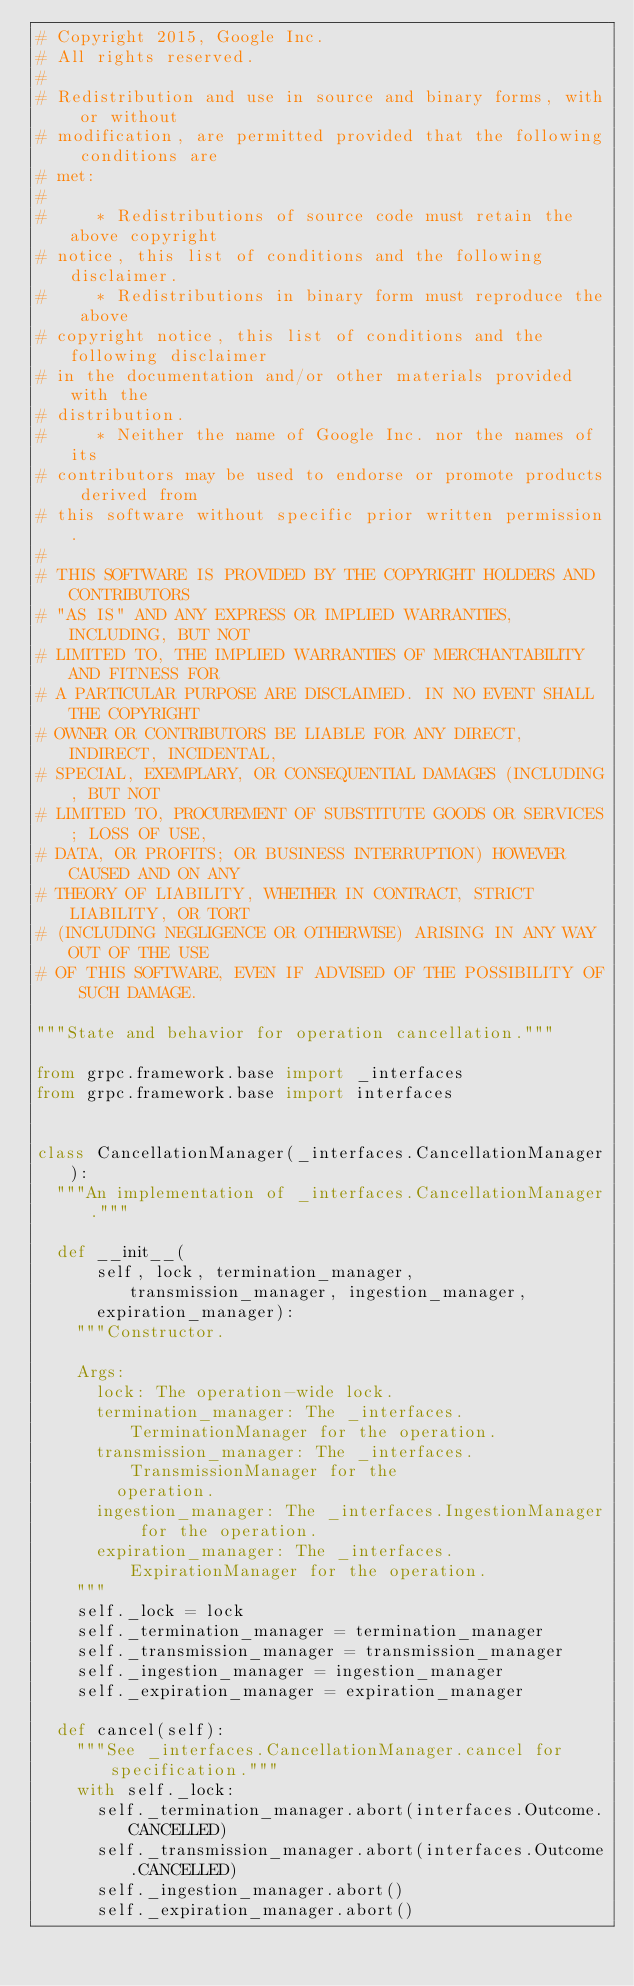Convert code to text. <code><loc_0><loc_0><loc_500><loc_500><_Python_># Copyright 2015, Google Inc.
# All rights reserved.
#
# Redistribution and use in source and binary forms, with or without
# modification, are permitted provided that the following conditions are
# met:
#
#     * Redistributions of source code must retain the above copyright
# notice, this list of conditions and the following disclaimer.
#     * Redistributions in binary form must reproduce the above
# copyright notice, this list of conditions and the following disclaimer
# in the documentation and/or other materials provided with the
# distribution.
#     * Neither the name of Google Inc. nor the names of its
# contributors may be used to endorse or promote products derived from
# this software without specific prior written permission.
#
# THIS SOFTWARE IS PROVIDED BY THE COPYRIGHT HOLDERS AND CONTRIBUTORS
# "AS IS" AND ANY EXPRESS OR IMPLIED WARRANTIES, INCLUDING, BUT NOT
# LIMITED TO, THE IMPLIED WARRANTIES OF MERCHANTABILITY AND FITNESS FOR
# A PARTICULAR PURPOSE ARE DISCLAIMED. IN NO EVENT SHALL THE COPYRIGHT
# OWNER OR CONTRIBUTORS BE LIABLE FOR ANY DIRECT, INDIRECT, INCIDENTAL,
# SPECIAL, EXEMPLARY, OR CONSEQUENTIAL DAMAGES (INCLUDING, BUT NOT
# LIMITED TO, PROCUREMENT OF SUBSTITUTE GOODS OR SERVICES; LOSS OF USE,
# DATA, OR PROFITS; OR BUSINESS INTERRUPTION) HOWEVER CAUSED AND ON ANY
# THEORY OF LIABILITY, WHETHER IN CONTRACT, STRICT LIABILITY, OR TORT
# (INCLUDING NEGLIGENCE OR OTHERWISE) ARISING IN ANY WAY OUT OF THE USE
# OF THIS SOFTWARE, EVEN IF ADVISED OF THE POSSIBILITY OF SUCH DAMAGE.

"""State and behavior for operation cancellation."""

from grpc.framework.base import _interfaces
from grpc.framework.base import interfaces


class CancellationManager(_interfaces.CancellationManager):
  """An implementation of _interfaces.CancellationManager."""

  def __init__(
      self, lock, termination_manager, transmission_manager, ingestion_manager,
      expiration_manager):
    """Constructor.

    Args:
      lock: The operation-wide lock.
      termination_manager: The _interfaces.TerminationManager for the operation.
      transmission_manager: The _interfaces.TransmissionManager for the
        operation.
      ingestion_manager: The _interfaces.IngestionManager for the operation.
      expiration_manager: The _interfaces.ExpirationManager for the operation.
    """
    self._lock = lock
    self._termination_manager = termination_manager
    self._transmission_manager = transmission_manager
    self._ingestion_manager = ingestion_manager
    self._expiration_manager = expiration_manager

  def cancel(self):
    """See _interfaces.CancellationManager.cancel for specification."""
    with self._lock:
      self._termination_manager.abort(interfaces.Outcome.CANCELLED)
      self._transmission_manager.abort(interfaces.Outcome.CANCELLED)
      self._ingestion_manager.abort()
      self._expiration_manager.abort()
</code> 